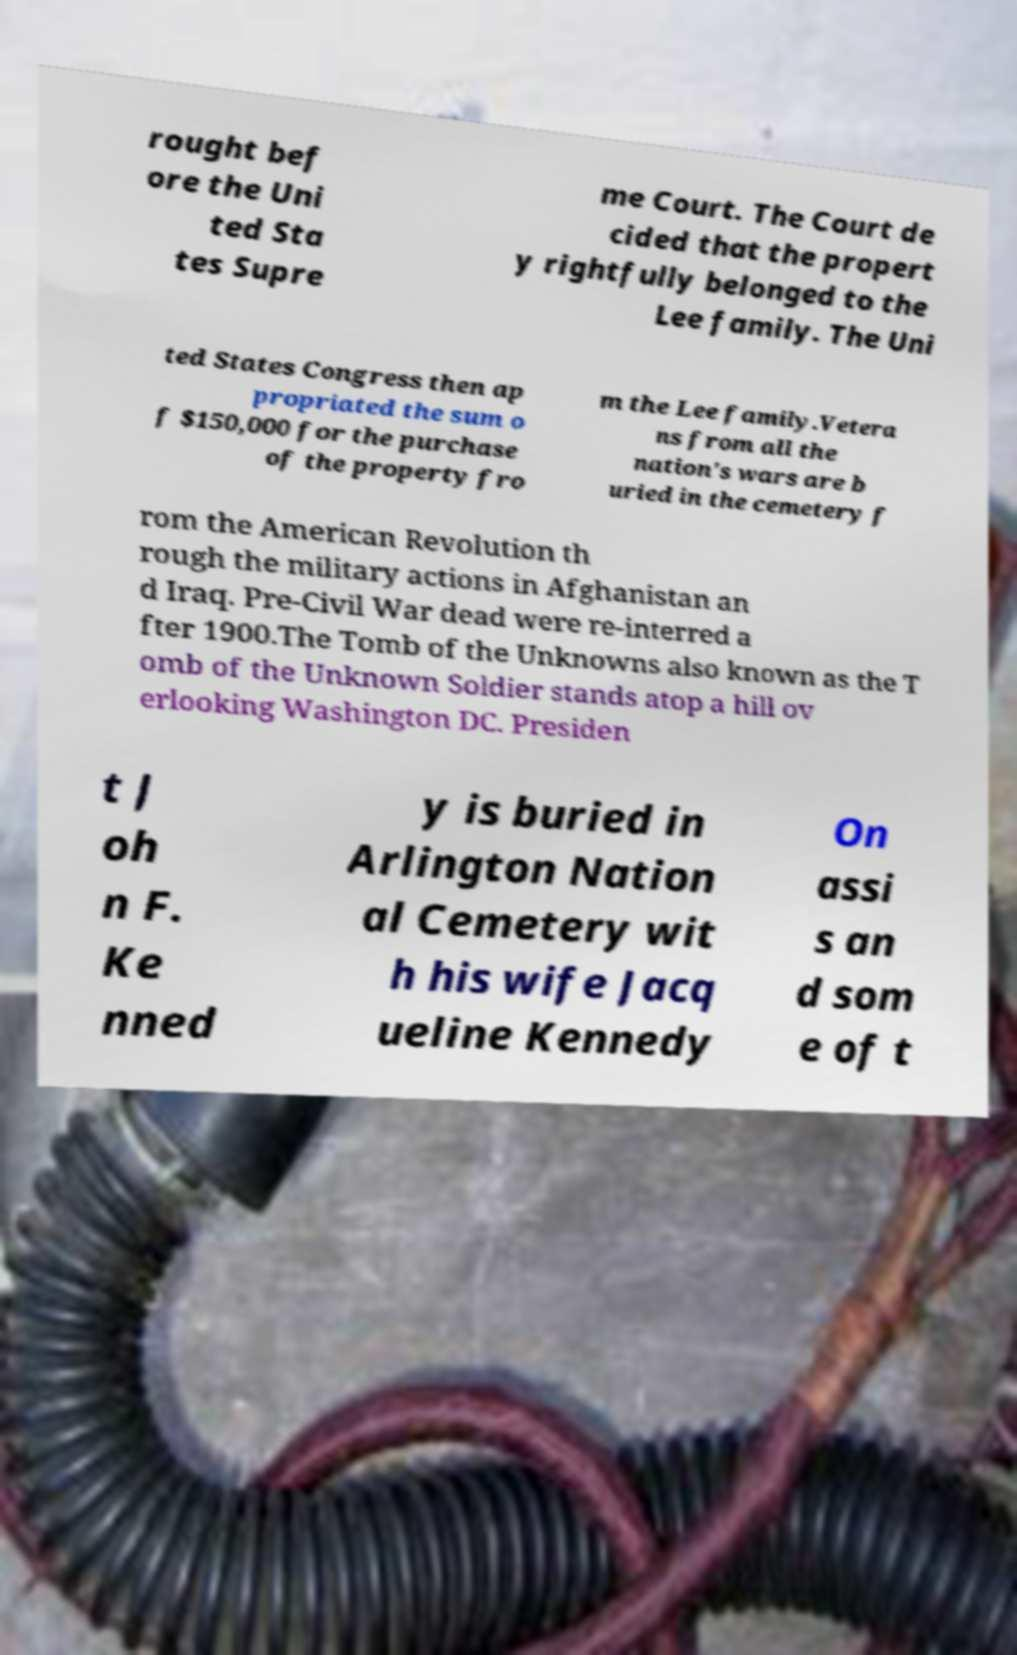I need the written content from this picture converted into text. Can you do that? rought bef ore the Uni ted Sta tes Supre me Court. The Court de cided that the propert y rightfully belonged to the Lee family. The Uni ted States Congress then ap propriated the sum o f $150,000 for the purchase of the property fro m the Lee family.Vetera ns from all the nation's wars are b uried in the cemetery f rom the American Revolution th rough the military actions in Afghanistan an d Iraq. Pre-Civil War dead were re-interred a fter 1900.The Tomb of the Unknowns also known as the T omb of the Unknown Soldier stands atop a hill ov erlooking Washington DC. Presiden t J oh n F. Ke nned y is buried in Arlington Nation al Cemetery wit h his wife Jacq ueline Kennedy On assi s an d som e of t 